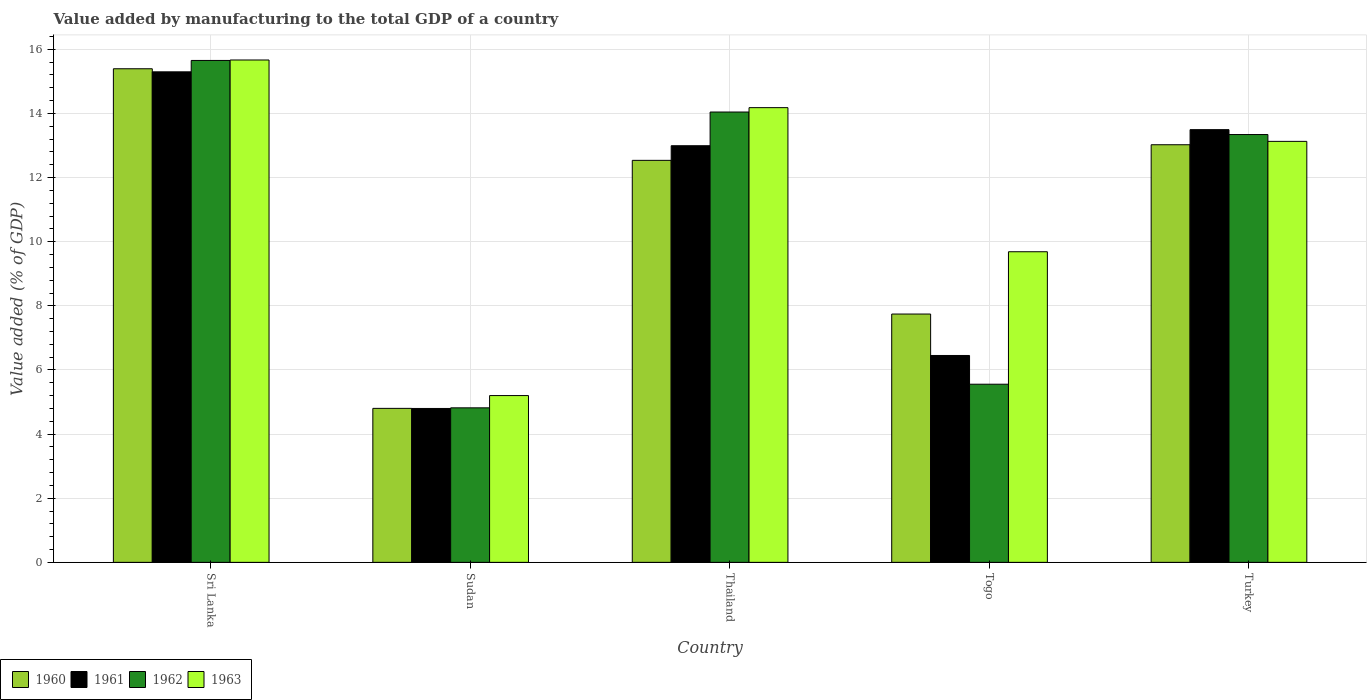How many different coloured bars are there?
Offer a very short reply. 4. How many bars are there on the 2nd tick from the left?
Your answer should be very brief. 4. How many bars are there on the 5th tick from the right?
Give a very brief answer. 4. In how many cases, is the number of bars for a given country not equal to the number of legend labels?
Ensure brevity in your answer.  0. What is the value added by manufacturing to the total GDP in 1963 in Togo?
Provide a succinct answer. 9.69. Across all countries, what is the maximum value added by manufacturing to the total GDP in 1963?
Offer a terse response. 15.67. Across all countries, what is the minimum value added by manufacturing to the total GDP in 1960?
Keep it short and to the point. 4.8. In which country was the value added by manufacturing to the total GDP in 1960 maximum?
Make the answer very short. Sri Lanka. In which country was the value added by manufacturing to the total GDP in 1963 minimum?
Provide a succinct answer. Sudan. What is the total value added by manufacturing to the total GDP in 1962 in the graph?
Provide a succinct answer. 53.41. What is the difference between the value added by manufacturing to the total GDP in 1963 in Sri Lanka and that in Turkey?
Ensure brevity in your answer.  2.54. What is the difference between the value added by manufacturing to the total GDP in 1962 in Sudan and the value added by manufacturing to the total GDP in 1961 in Togo?
Your answer should be compact. -1.63. What is the average value added by manufacturing to the total GDP in 1962 per country?
Make the answer very short. 10.68. What is the difference between the value added by manufacturing to the total GDP of/in 1960 and value added by manufacturing to the total GDP of/in 1961 in Togo?
Your answer should be compact. 1.29. What is the ratio of the value added by manufacturing to the total GDP in 1963 in Sudan to that in Thailand?
Offer a terse response. 0.37. Is the value added by manufacturing to the total GDP in 1961 in Thailand less than that in Togo?
Ensure brevity in your answer.  No. Is the difference between the value added by manufacturing to the total GDP in 1960 in Thailand and Togo greater than the difference between the value added by manufacturing to the total GDP in 1961 in Thailand and Togo?
Offer a very short reply. No. What is the difference between the highest and the second highest value added by manufacturing to the total GDP in 1963?
Keep it short and to the point. -1.05. What is the difference between the highest and the lowest value added by manufacturing to the total GDP in 1960?
Ensure brevity in your answer.  10.59. Is the sum of the value added by manufacturing to the total GDP in 1963 in Thailand and Turkey greater than the maximum value added by manufacturing to the total GDP in 1962 across all countries?
Ensure brevity in your answer.  Yes. Is it the case that in every country, the sum of the value added by manufacturing to the total GDP in 1963 and value added by manufacturing to the total GDP in 1960 is greater than the sum of value added by manufacturing to the total GDP in 1962 and value added by manufacturing to the total GDP in 1961?
Provide a succinct answer. No. What does the 4th bar from the left in Togo represents?
Offer a very short reply. 1963. Is it the case that in every country, the sum of the value added by manufacturing to the total GDP in 1960 and value added by manufacturing to the total GDP in 1963 is greater than the value added by manufacturing to the total GDP in 1961?
Your answer should be compact. Yes. What is the difference between two consecutive major ticks on the Y-axis?
Provide a succinct answer. 2. Are the values on the major ticks of Y-axis written in scientific E-notation?
Offer a terse response. No. Does the graph contain grids?
Ensure brevity in your answer.  Yes. Where does the legend appear in the graph?
Your answer should be very brief. Bottom left. How many legend labels are there?
Make the answer very short. 4. What is the title of the graph?
Make the answer very short. Value added by manufacturing to the total GDP of a country. What is the label or title of the X-axis?
Offer a very short reply. Country. What is the label or title of the Y-axis?
Provide a succinct answer. Value added (% of GDP). What is the Value added (% of GDP) in 1960 in Sri Lanka?
Your response must be concise. 15.39. What is the Value added (% of GDP) in 1961 in Sri Lanka?
Make the answer very short. 15.3. What is the Value added (% of GDP) in 1962 in Sri Lanka?
Provide a short and direct response. 15.65. What is the Value added (% of GDP) of 1963 in Sri Lanka?
Your response must be concise. 15.67. What is the Value added (% of GDP) of 1960 in Sudan?
Keep it short and to the point. 4.8. What is the Value added (% of GDP) of 1961 in Sudan?
Make the answer very short. 4.8. What is the Value added (% of GDP) of 1962 in Sudan?
Provide a succinct answer. 4.82. What is the Value added (% of GDP) in 1963 in Sudan?
Provide a succinct answer. 5.2. What is the Value added (% of GDP) of 1960 in Thailand?
Provide a short and direct response. 12.54. What is the Value added (% of GDP) of 1961 in Thailand?
Your answer should be very brief. 12.99. What is the Value added (% of GDP) in 1962 in Thailand?
Make the answer very short. 14.04. What is the Value added (% of GDP) in 1963 in Thailand?
Provide a short and direct response. 14.18. What is the Value added (% of GDP) of 1960 in Togo?
Offer a very short reply. 7.74. What is the Value added (% of GDP) in 1961 in Togo?
Your answer should be very brief. 6.45. What is the Value added (% of GDP) in 1962 in Togo?
Provide a succinct answer. 5.56. What is the Value added (% of GDP) in 1963 in Togo?
Your answer should be very brief. 9.69. What is the Value added (% of GDP) of 1960 in Turkey?
Give a very brief answer. 13.02. What is the Value added (% of GDP) of 1961 in Turkey?
Offer a very short reply. 13.49. What is the Value added (% of GDP) of 1962 in Turkey?
Your answer should be very brief. 13.34. What is the Value added (% of GDP) of 1963 in Turkey?
Make the answer very short. 13.13. Across all countries, what is the maximum Value added (% of GDP) in 1960?
Ensure brevity in your answer.  15.39. Across all countries, what is the maximum Value added (% of GDP) in 1961?
Provide a succinct answer. 15.3. Across all countries, what is the maximum Value added (% of GDP) in 1962?
Ensure brevity in your answer.  15.65. Across all countries, what is the maximum Value added (% of GDP) of 1963?
Offer a terse response. 15.67. Across all countries, what is the minimum Value added (% of GDP) in 1960?
Give a very brief answer. 4.8. Across all countries, what is the minimum Value added (% of GDP) in 1961?
Offer a very short reply. 4.8. Across all countries, what is the minimum Value added (% of GDP) of 1962?
Your response must be concise. 4.82. Across all countries, what is the minimum Value added (% of GDP) of 1963?
Provide a short and direct response. 5.2. What is the total Value added (% of GDP) in 1960 in the graph?
Keep it short and to the point. 53.5. What is the total Value added (% of GDP) of 1961 in the graph?
Provide a succinct answer. 53.04. What is the total Value added (% of GDP) in 1962 in the graph?
Provide a succinct answer. 53.41. What is the total Value added (% of GDP) of 1963 in the graph?
Offer a terse response. 57.86. What is the difference between the Value added (% of GDP) in 1960 in Sri Lanka and that in Sudan?
Give a very brief answer. 10.59. What is the difference between the Value added (% of GDP) in 1961 in Sri Lanka and that in Sudan?
Keep it short and to the point. 10.5. What is the difference between the Value added (% of GDP) of 1962 in Sri Lanka and that in Sudan?
Keep it short and to the point. 10.83. What is the difference between the Value added (% of GDP) of 1963 in Sri Lanka and that in Sudan?
Provide a succinct answer. 10.47. What is the difference between the Value added (% of GDP) of 1960 in Sri Lanka and that in Thailand?
Offer a very short reply. 2.86. What is the difference between the Value added (% of GDP) of 1961 in Sri Lanka and that in Thailand?
Provide a short and direct response. 2.3. What is the difference between the Value added (% of GDP) of 1962 in Sri Lanka and that in Thailand?
Keep it short and to the point. 1.61. What is the difference between the Value added (% of GDP) in 1963 in Sri Lanka and that in Thailand?
Offer a terse response. 1.49. What is the difference between the Value added (% of GDP) in 1960 in Sri Lanka and that in Togo?
Provide a succinct answer. 7.65. What is the difference between the Value added (% of GDP) in 1961 in Sri Lanka and that in Togo?
Give a very brief answer. 8.85. What is the difference between the Value added (% of GDP) of 1962 in Sri Lanka and that in Togo?
Make the answer very short. 10.1. What is the difference between the Value added (% of GDP) in 1963 in Sri Lanka and that in Togo?
Your answer should be compact. 5.98. What is the difference between the Value added (% of GDP) of 1960 in Sri Lanka and that in Turkey?
Make the answer very short. 2.37. What is the difference between the Value added (% of GDP) of 1961 in Sri Lanka and that in Turkey?
Keep it short and to the point. 1.8. What is the difference between the Value added (% of GDP) in 1962 in Sri Lanka and that in Turkey?
Your answer should be compact. 2.31. What is the difference between the Value added (% of GDP) of 1963 in Sri Lanka and that in Turkey?
Make the answer very short. 2.54. What is the difference between the Value added (% of GDP) in 1960 in Sudan and that in Thailand?
Your response must be concise. -7.73. What is the difference between the Value added (% of GDP) of 1961 in Sudan and that in Thailand?
Your answer should be compact. -8.19. What is the difference between the Value added (% of GDP) in 1962 in Sudan and that in Thailand?
Keep it short and to the point. -9.23. What is the difference between the Value added (% of GDP) in 1963 in Sudan and that in Thailand?
Keep it short and to the point. -8.98. What is the difference between the Value added (% of GDP) in 1960 in Sudan and that in Togo?
Offer a very short reply. -2.94. What is the difference between the Value added (% of GDP) in 1961 in Sudan and that in Togo?
Your answer should be compact. -1.65. What is the difference between the Value added (% of GDP) in 1962 in Sudan and that in Togo?
Provide a succinct answer. -0.74. What is the difference between the Value added (% of GDP) of 1963 in Sudan and that in Togo?
Offer a terse response. -4.49. What is the difference between the Value added (% of GDP) of 1960 in Sudan and that in Turkey?
Ensure brevity in your answer.  -8.22. What is the difference between the Value added (% of GDP) of 1961 in Sudan and that in Turkey?
Ensure brevity in your answer.  -8.69. What is the difference between the Value added (% of GDP) in 1962 in Sudan and that in Turkey?
Keep it short and to the point. -8.52. What is the difference between the Value added (% of GDP) of 1963 in Sudan and that in Turkey?
Offer a very short reply. -7.93. What is the difference between the Value added (% of GDP) in 1960 in Thailand and that in Togo?
Keep it short and to the point. 4.79. What is the difference between the Value added (% of GDP) of 1961 in Thailand and that in Togo?
Provide a short and direct response. 6.54. What is the difference between the Value added (% of GDP) of 1962 in Thailand and that in Togo?
Make the answer very short. 8.49. What is the difference between the Value added (% of GDP) of 1963 in Thailand and that in Togo?
Make the answer very short. 4.49. What is the difference between the Value added (% of GDP) of 1960 in Thailand and that in Turkey?
Make the answer very short. -0.49. What is the difference between the Value added (% of GDP) in 1961 in Thailand and that in Turkey?
Your response must be concise. -0.5. What is the difference between the Value added (% of GDP) in 1962 in Thailand and that in Turkey?
Your response must be concise. 0.7. What is the difference between the Value added (% of GDP) in 1963 in Thailand and that in Turkey?
Offer a terse response. 1.05. What is the difference between the Value added (% of GDP) of 1960 in Togo and that in Turkey?
Offer a very short reply. -5.28. What is the difference between the Value added (% of GDP) in 1961 in Togo and that in Turkey?
Provide a succinct answer. -7.04. What is the difference between the Value added (% of GDP) of 1962 in Togo and that in Turkey?
Offer a terse response. -7.79. What is the difference between the Value added (% of GDP) of 1963 in Togo and that in Turkey?
Your answer should be very brief. -3.44. What is the difference between the Value added (% of GDP) of 1960 in Sri Lanka and the Value added (% of GDP) of 1961 in Sudan?
Make the answer very short. 10.59. What is the difference between the Value added (% of GDP) in 1960 in Sri Lanka and the Value added (% of GDP) in 1962 in Sudan?
Offer a very short reply. 10.57. What is the difference between the Value added (% of GDP) of 1960 in Sri Lanka and the Value added (% of GDP) of 1963 in Sudan?
Offer a very short reply. 10.19. What is the difference between the Value added (% of GDP) in 1961 in Sri Lanka and the Value added (% of GDP) in 1962 in Sudan?
Offer a terse response. 10.48. What is the difference between the Value added (% of GDP) in 1961 in Sri Lanka and the Value added (% of GDP) in 1963 in Sudan?
Offer a very short reply. 10.1. What is the difference between the Value added (% of GDP) of 1962 in Sri Lanka and the Value added (% of GDP) of 1963 in Sudan?
Your answer should be very brief. 10.45. What is the difference between the Value added (% of GDP) in 1960 in Sri Lanka and the Value added (% of GDP) in 1961 in Thailand?
Provide a short and direct response. 2.4. What is the difference between the Value added (% of GDP) of 1960 in Sri Lanka and the Value added (% of GDP) of 1962 in Thailand?
Provide a short and direct response. 1.35. What is the difference between the Value added (% of GDP) in 1960 in Sri Lanka and the Value added (% of GDP) in 1963 in Thailand?
Your response must be concise. 1.21. What is the difference between the Value added (% of GDP) of 1961 in Sri Lanka and the Value added (% of GDP) of 1962 in Thailand?
Your answer should be compact. 1.25. What is the difference between the Value added (% of GDP) of 1961 in Sri Lanka and the Value added (% of GDP) of 1963 in Thailand?
Provide a short and direct response. 1.12. What is the difference between the Value added (% of GDP) of 1962 in Sri Lanka and the Value added (% of GDP) of 1963 in Thailand?
Ensure brevity in your answer.  1.47. What is the difference between the Value added (% of GDP) of 1960 in Sri Lanka and the Value added (% of GDP) of 1961 in Togo?
Your answer should be compact. 8.94. What is the difference between the Value added (% of GDP) in 1960 in Sri Lanka and the Value added (% of GDP) in 1962 in Togo?
Your answer should be very brief. 9.84. What is the difference between the Value added (% of GDP) of 1960 in Sri Lanka and the Value added (% of GDP) of 1963 in Togo?
Make the answer very short. 5.71. What is the difference between the Value added (% of GDP) in 1961 in Sri Lanka and the Value added (% of GDP) in 1962 in Togo?
Offer a terse response. 9.74. What is the difference between the Value added (% of GDP) in 1961 in Sri Lanka and the Value added (% of GDP) in 1963 in Togo?
Your answer should be very brief. 5.61. What is the difference between the Value added (% of GDP) of 1962 in Sri Lanka and the Value added (% of GDP) of 1963 in Togo?
Your answer should be compact. 5.97. What is the difference between the Value added (% of GDP) in 1960 in Sri Lanka and the Value added (% of GDP) in 1961 in Turkey?
Your answer should be compact. 1.9. What is the difference between the Value added (% of GDP) of 1960 in Sri Lanka and the Value added (% of GDP) of 1962 in Turkey?
Make the answer very short. 2.05. What is the difference between the Value added (% of GDP) in 1960 in Sri Lanka and the Value added (% of GDP) in 1963 in Turkey?
Keep it short and to the point. 2.26. What is the difference between the Value added (% of GDP) of 1961 in Sri Lanka and the Value added (% of GDP) of 1962 in Turkey?
Your answer should be very brief. 1.96. What is the difference between the Value added (% of GDP) of 1961 in Sri Lanka and the Value added (% of GDP) of 1963 in Turkey?
Ensure brevity in your answer.  2.17. What is the difference between the Value added (% of GDP) of 1962 in Sri Lanka and the Value added (% of GDP) of 1963 in Turkey?
Ensure brevity in your answer.  2.52. What is the difference between the Value added (% of GDP) of 1960 in Sudan and the Value added (% of GDP) of 1961 in Thailand?
Ensure brevity in your answer.  -8.19. What is the difference between the Value added (% of GDP) in 1960 in Sudan and the Value added (% of GDP) in 1962 in Thailand?
Give a very brief answer. -9.24. What is the difference between the Value added (% of GDP) in 1960 in Sudan and the Value added (% of GDP) in 1963 in Thailand?
Give a very brief answer. -9.38. What is the difference between the Value added (% of GDP) in 1961 in Sudan and the Value added (% of GDP) in 1962 in Thailand?
Your response must be concise. -9.24. What is the difference between the Value added (% of GDP) of 1961 in Sudan and the Value added (% of GDP) of 1963 in Thailand?
Provide a succinct answer. -9.38. What is the difference between the Value added (% of GDP) in 1962 in Sudan and the Value added (% of GDP) in 1963 in Thailand?
Your response must be concise. -9.36. What is the difference between the Value added (% of GDP) of 1960 in Sudan and the Value added (% of GDP) of 1961 in Togo?
Your response must be concise. -1.65. What is the difference between the Value added (% of GDP) in 1960 in Sudan and the Value added (% of GDP) in 1962 in Togo?
Your answer should be compact. -0.75. What is the difference between the Value added (% of GDP) of 1960 in Sudan and the Value added (% of GDP) of 1963 in Togo?
Ensure brevity in your answer.  -4.88. What is the difference between the Value added (% of GDP) of 1961 in Sudan and the Value added (% of GDP) of 1962 in Togo?
Your answer should be compact. -0.76. What is the difference between the Value added (% of GDP) of 1961 in Sudan and the Value added (% of GDP) of 1963 in Togo?
Offer a terse response. -4.89. What is the difference between the Value added (% of GDP) in 1962 in Sudan and the Value added (% of GDP) in 1963 in Togo?
Give a very brief answer. -4.87. What is the difference between the Value added (% of GDP) of 1960 in Sudan and the Value added (% of GDP) of 1961 in Turkey?
Provide a succinct answer. -8.69. What is the difference between the Value added (% of GDP) of 1960 in Sudan and the Value added (% of GDP) of 1962 in Turkey?
Offer a terse response. -8.54. What is the difference between the Value added (% of GDP) in 1960 in Sudan and the Value added (% of GDP) in 1963 in Turkey?
Your answer should be very brief. -8.33. What is the difference between the Value added (% of GDP) of 1961 in Sudan and the Value added (% of GDP) of 1962 in Turkey?
Provide a succinct answer. -8.54. What is the difference between the Value added (% of GDP) of 1961 in Sudan and the Value added (% of GDP) of 1963 in Turkey?
Make the answer very short. -8.33. What is the difference between the Value added (% of GDP) in 1962 in Sudan and the Value added (% of GDP) in 1963 in Turkey?
Your response must be concise. -8.31. What is the difference between the Value added (% of GDP) of 1960 in Thailand and the Value added (% of GDP) of 1961 in Togo?
Your response must be concise. 6.09. What is the difference between the Value added (% of GDP) in 1960 in Thailand and the Value added (% of GDP) in 1962 in Togo?
Ensure brevity in your answer.  6.98. What is the difference between the Value added (% of GDP) of 1960 in Thailand and the Value added (% of GDP) of 1963 in Togo?
Offer a terse response. 2.85. What is the difference between the Value added (% of GDP) in 1961 in Thailand and the Value added (% of GDP) in 1962 in Togo?
Provide a succinct answer. 7.44. What is the difference between the Value added (% of GDP) in 1961 in Thailand and the Value added (% of GDP) in 1963 in Togo?
Give a very brief answer. 3.31. What is the difference between the Value added (% of GDP) in 1962 in Thailand and the Value added (% of GDP) in 1963 in Togo?
Give a very brief answer. 4.36. What is the difference between the Value added (% of GDP) in 1960 in Thailand and the Value added (% of GDP) in 1961 in Turkey?
Provide a succinct answer. -0.96. What is the difference between the Value added (% of GDP) of 1960 in Thailand and the Value added (% of GDP) of 1962 in Turkey?
Offer a very short reply. -0.81. What is the difference between the Value added (% of GDP) in 1960 in Thailand and the Value added (% of GDP) in 1963 in Turkey?
Ensure brevity in your answer.  -0.59. What is the difference between the Value added (% of GDP) in 1961 in Thailand and the Value added (% of GDP) in 1962 in Turkey?
Provide a succinct answer. -0.35. What is the difference between the Value added (% of GDP) of 1961 in Thailand and the Value added (% of GDP) of 1963 in Turkey?
Provide a succinct answer. -0.14. What is the difference between the Value added (% of GDP) in 1962 in Thailand and the Value added (% of GDP) in 1963 in Turkey?
Make the answer very short. 0.92. What is the difference between the Value added (% of GDP) of 1960 in Togo and the Value added (% of GDP) of 1961 in Turkey?
Ensure brevity in your answer.  -5.75. What is the difference between the Value added (% of GDP) in 1960 in Togo and the Value added (% of GDP) in 1962 in Turkey?
Your answer should be very brief. -5.6. What is the difference between the Value added (% of GDP) of 1960 in Togo and the Value added (% of GDP) of 1963 in Turkey?
Offer a very short reply. -5.38. What is the difference between the Value added (% of GDP) of 1961 in Togo and the Value added (% of GDP) of 1962 in Turkey?
Provide a succinct answer. -6.89. What is the difference between the Value added (% of GDP) of 1961 in Togo and the Value added (% of GDP) of 1963 in Turkey?
Give a very brief answer. -6.68. What is the difference between the Value added (% of GDP) in 1962 in Togo and the Value added (% of GDP) in 1963 in Turkey?
Your answer should be very brief. -7.57. What is the average Value added (% of GDP) in 1960 per country?
Ensure brevity in your answer.  10.7. What is the average Value added (% of GDP) of 1961 per country?
Your answer should be very brief. 10.61. What is the average Value added (% of GDP) in 1962 per country?
Make the answer very short. 10.68. What is the average Value added (% of GDP) of 1963 per country?
Give a very brief answer. 11.57. What is the difference between the Value added (% of GDP) in 1960 and Value added (% of GDP) in 1961 in Sri Lanka?
Your answer should be compact. 0.1. What is the difference between the Value added (% of GDP) in 1960 and Value added (% of GDP) in 1962 in Sri Lanka?
Keep it short and to the point. -0.26. What is the difference between the Value added (% of GDP) of 1960 and Value added (% of GDP) of 1963 in Sri Lanka?
Your response must be concise. -0.27. What is the difference between the Value added (% of GDP) in 1961 and Value added (% of GDP) in 1962 in Sri Lanka?
Ensure brevity in your answer.  -0.35. What is the difference between the Value added (% of GDP) in 1961 and Value added (% of GDP) in 1963 in Sri Lanka?
Offer a very short reply. -0.37. What is the difference between the Value added (% of GDP) in 1962 and Value added (% of GDP) in 1963 in Sri Lanka?
Make the answer very short. -0.01. What is the difference between the Value added (% of GDP) of 1960 and Value added (% of GDP) of 1961 in Sudan?
Your response must be concise. 0. What is the difference between the Value added (% of GDP) of 1960 and Value added (% of GDP) of 1962 in Sudan?
Your response must be concise. -0.02. What is the difference between the Value added (% of GDP) in 1960 and Value added (% of GDP) in 1963 in Sudan?
Provide a succinct answer. -0.4. What is the difference between the Value added (% of GDP) in 1961 and Value added (% of GDP) in 1962 in Sudan?
Your response must be concise. -0.02. What is the difference between the Value added (% of GDP) in 1961 and Value added (% of GDP) in 1963 in Sudan?
Offer a very short reply. -0.4. What is the difference between the Value added (% of GDP) in 1962 and Value added (% of GDP) in 1963 in Sudan?
Make the answer very short. -0.38. What is the difference between the Value added (% of GDP) of 1960 and Value added (% of GDP) of 1961 in Thailand?
Keep it short and to the point. -0.46. What is the difference between the Value added (% of GDP) in 1960 and Value added (% of GDP) in 1962 in Thailand?
Keep it short and to the point. -1.51. What is the difference between the Value added (% of GDP) of 1960 and Value added (% of GDP) of 1963 in Thailand?
Provide a succinct answer. -1.64. What is the difference between the Value added (% of GDP) in 1961 and Value added (% of GDP) in 1962 in Thailand?
Offer a terse response. -1.05. What is the difference between the Value added (% of GDP) in 1961 and Value added (% of GDP) in 1963 in Thailand?
Your answer should be very brief. -1.19. What is the difference between the Value added (% of GDP) in 1962 and Value added (% of GDP) in 1963 in Thailand?
Make the answer very short. -0.14. What is the difference between the Value added (% of GDP) in 1960 and Value added (% of GDP) in 1961 in Togo?
Keep it short and to the point. 1.29. What is the difference between the Value added (% of GDP) in 1960 and Value added (% of GDP) in 1962 in Togo?
Your answer should be very brief. 2.19. What is the difference between the Value added (% of GDP) in 1960 and Value added (% of GDP) in 1963 in Togo?
Ensure brevity in your answer.  -1.94. What is the difference between the Value added (% of GDP) of 1961 and Value added (% of GDP) of 1962 in Togo?
Your response must be concise. 0.9. What is the difference between the Value added (% of GDP) of 1961 and Value added (% of GDP) of 1963 in Togo?
Your response must be concise. -3.23. What is the difference between the Value added (% of GDP) in 1962 and Value added (% of GDP) in 1963 in Togo?
Your answer should be very brief. -4.13. What is the difference between the Value added (% of GDP) in 1960 and Value added (% of GDP) in 1961 in Turkey?
Make the answer very short. -0.47. What is the difference between the Value added (% of GDP) of 1960 and Value added (% of GDP) of 1962 in Turkey?
Your answer should be very brief. -0.32. What is the difference between the Value added (% of GDP) in 1960 and Value added (% of GDP) in 1963 in Turkey?
Your response must be concise. -0.11. What is the difference between the Value added (% of GDP) of 1961 and Value added (% of GDP) of 1962 in Turkey?
Make the answer very short. 0.15. What is the difference between the Value added (% of GDP) of 1961 and Value added (% of GDP) of 1963 in Turkey?
Give a very brief answer. 0.37. What is the difference between the Value added (% of GDP) of 1962 and Value added (% of GDP) of 1963 in Turkey?
Offer a terse response. 0.21. What is the ratio of the Value added (% of GDP) of 1960 in Sri Lanka to that in Sudan?
Provide a succinct answer. 3.21. What is the ratio of the Value added (% of GDP) in 1961 in Sri Lanka to that in Sudan?
Offer a very short reply. 3.19. What is the ratio of the Value added (% of GDP) in 1962 in Sri Lanka to that in Sudan?
Your response must be concise. 3.25. What is the ratio of the Value added (% of GDP) of 1963 in Sri Lanka to that in Sudan?
Give a very brief answer. 3.01. What is the ratio of the Value added (% of GDP) in 1960 in Sri Lanka to that in Thailand?
Your answer should be compact. 1.23. What is the ratio of the Value added (% of GDP) in 1961 in Sri Lanka to that in Thailand?
Make the answer very short. 1.18. What is the ratio of the Value added (% of GDP) in 1962 in Sri Lanka to that in Thailand?
Ensure brevity in your answer.  1.11. What is the ratio of the Value added (% of GDP) in 1963 in Sri Lanka to that in Thailand?
Your answer should be very brief. 1.1. What is the ratio of the Value added (% of GDP) in 1960 in Sri Lanka to that in Togo?
Provide a short and direct response. 1.99. What is the ratio of the Value added (% of GDP) in 1961 in Sri Lanka to that in Togo?
Provide a short and direct response. 2.37. What is the ratio of the Value added (% of GDP) in 1962 in Sri Lanka to that in Togo?
Provide a short and direct response. 2.82. What is the ratio of the Value added (% of GDP) of 1963 in Sri Lanka to that in Togo?
Provide a short and direct response. 1.62. What is the ratio of the Value added (% of GDP) in 1960 in Sri Lanka to that in Turkey?
Your answer should be compact. 1.18. What is the ratio of the Value added (% of GDP) in 1961 in Sri Lanka to that in Turkey?
Ensure brevity in your answer.  1.13. What is the ratio of the Value added (% of GDP) of 1962 in Sri Lanka to that in Turkey?
Give a very brief answer. 1.17. What is the ratio of the Value added (% of GDP) in 1963 in Sri Lanka to that in Turkey?
Your response must be concise. 1.19. What is the ratio of the Value added (% of GDP) in 1960 in Sudan to that in Thailand?
Your response must be concise. 0.38. What is the ratio of the Value added (% of GDP) of 1961 in Sudan to that in Thailand?
Your answer should be compact. 0.37. What is the ratio of the Value added (% of GDP) of 1962 in Sudan to that in Thailand?
Keep it short and to the point. 0.34. What is the ratio of the Value added (% of GDP) of 1963 in Sudan to that in Thailand?
Give a very brief answer. 0.37. What is the ratio of the Value added (% of GDP) in 1960 in Sudan to that in Togo?
Offer a very short reply. 0.62. What is the ratio of the Value added (% of GDP) of 1961 in Sudan to that in Togo?
Provide a succinct answer. 0.74. What is the ratio of the Value added (% of GDP) in 1962 in Sudan to that in Togo?
Provide a short and direct response. 0.87. What is the ratio of the Value added (% of GDP) of 1963 in Sudan to that in Togo?
Provide a short and direct response. 0.54. What is the ratio of the Value added (% of GDP) of 1960 in Sudan to that in Turkey?
Provide a short and direct response. 0.37. What is the ratio of the Value added (% of GDP) of 1961 in Sudan to that in Turkey?
Your response must be concise. 0.36. What is the ratio of the Value added (% of GDP) in 1962 in Sudan to that in Turkey?
Offer a very short reply. 0.36. What is the ratio of the Value added (% of GDP) in 1963 in Sudan to that in Turkey?
Your response must be concise. 0.4. What is the ratio of the Value added (% of GDP) in 1960 in Thailand to that in Togo?
Keep it short and to the point. 1.62. What is the ratio of the Value added (% of GDP) of 1961 in Thailand to that in Togo?
Provide a succinct answer. 2.01. What is the ratio of the Value added (% of GDP) of 1962 in Thailand to that in Togo?
Keep it short and to the point. 2.53. What is the ratio of the Value added (% of GDP) of 1963 in Thailand to that in Togo?
Provide a succinct answer. 1.46. What is the ratio of the Value added (% of GDP) in 1960 in Thailand to that in Turkey?
Provide a short and direct response. 0.96. What is the ratio of the Value added (% of GDP) of 1961 in Thailand to that in Turkey?
Provide a succinct answer. 0.96. What is the ratio of the Value added (% of GDP) of 1962 in Thailand to that in Turkey?
Your answer should be compact. 1.05. What is the ratio of the Value added (% of GDP) of 1963 in Thailand to that in Turkey?
Offer a terse response. 1.08. What is the ratio of the Value added (% of GDP) of 1960 in Togo to that in Turkey?
Your response must be concise. 0.59. What is the ratio of the Value added (% of GDP) in 1961 in Togo to that in Turkey?
Make the answer very short. 0.48. What is the ratio of the Value added (% of GDP) in 1962 in Togo to that in Turkey?
Provide a succinct answer. 0.42. What is the ratio of the Value added (% of GDP) in 1963 in Togo to that in Turkey?
Your answer should be compact. 0.74. What is the difference between the highest and the second highest Value added (% of GDP) of 1960?
Ensure brevity in your answer.  2.37. What is the difference between the highest and the second highest Value added (% of GDP) of 1961?
Offer a very short reply. 1.8. What is the difference between the highest and the second highest Value added (% of GDP) in 1962?
Provide a succinct answer. 1.61. What is the difference between the highest and the second highest Value added (% of GDP) of 1963?
Your response must be concise. 1.49. What is the difference between the highest and the lowest Value added (% of GDP) in 1960?
Offer a terse response. 10.59. What is the difference between the highest and the lowest Value added (% of GDP) in 1961?
Offer a terse response. 10.5. What is the difference between the highest and the lowest Value added (% of GDP) in 1962?
Provide a succinct answer. 10.83. What is the difference between the highest and the lowest Value added (% of GDP) of 1963?
Give a very brief answer. 10.47. 